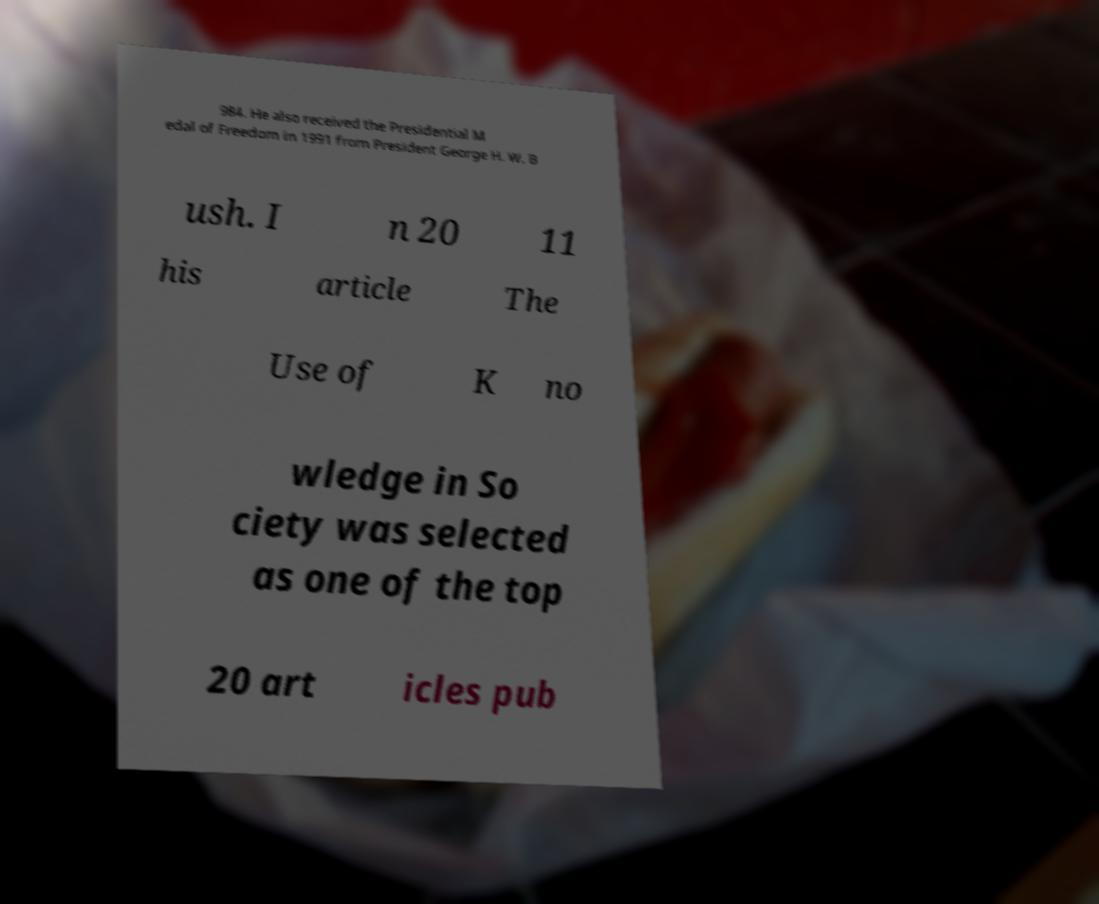I need the written content from this picture converted into text. Can you do that? 984. He also received the Presidential M edal of Freedom in 1991 from President George H. W. B ush. I n 20 11 his article The Use of K no wledge in So ciety was selected as one of the top 20 art icles pub 